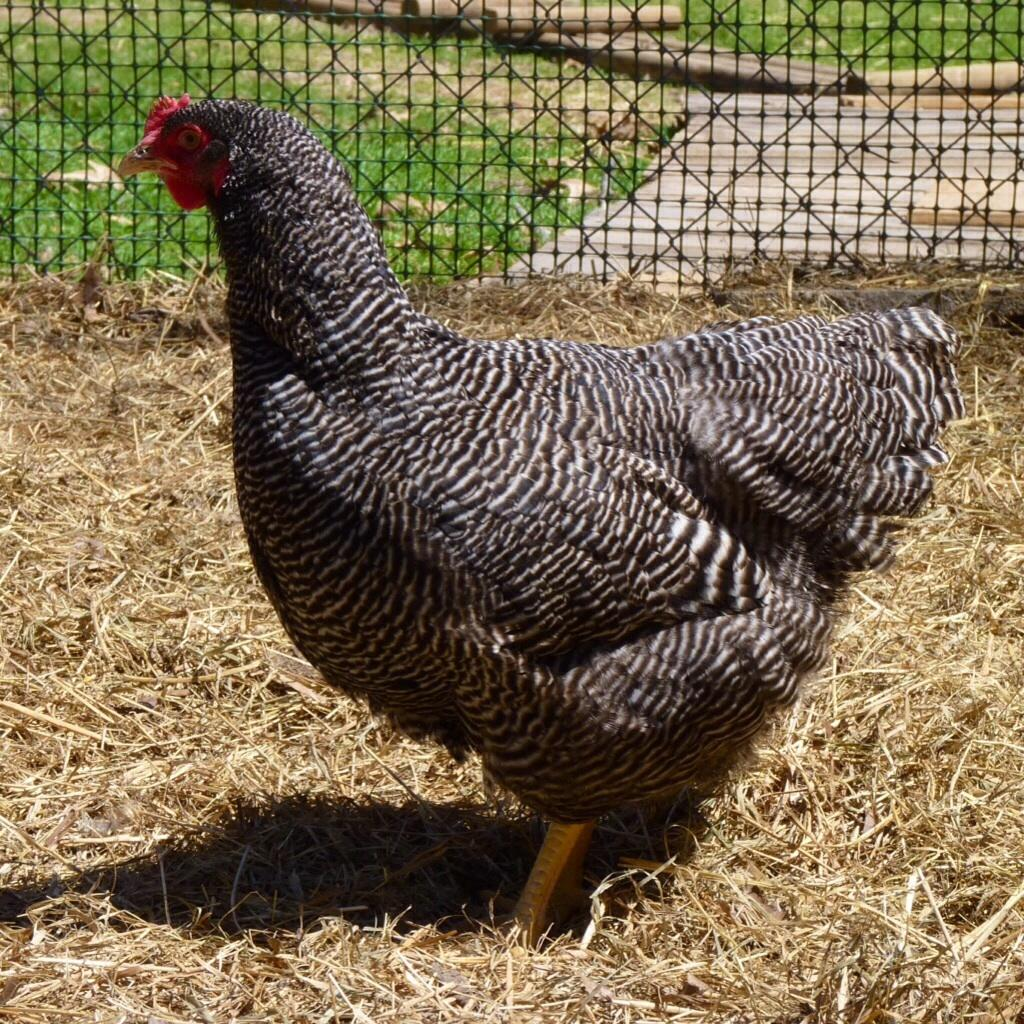What is hung in the center of the image? There is an object hung in the center of the image. What is the floor made of in the image? The floor in the image consists of dried grass. What type of vegetation can be seen in the image? There is greenery visible in the image. What is located at the top side of the image? There is a net at the top side of the image. What shape is the rice in the image? There is no rice present in the image, so it is not possible to determine the shape of any rice. 